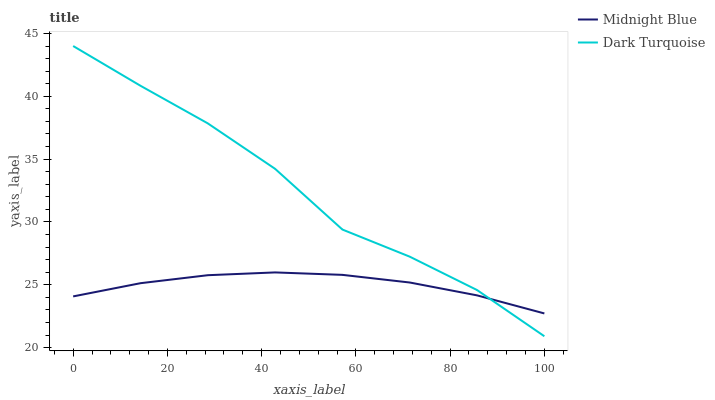Does Midnight Blue have the minimum area under the curve?
Answer yes or no. Yes. Does Dark Turquoise have the maximum area under the curve?
Answer yes or no. Yes. Does Midnight Blue have the maximum area under the curve?
Answer yes or no. No. Is Midnight Blue the smoothest?
Answer yes or no. Yes. Is Dark Turquoise the roughest?
Answer yes or no. Yes. Is Midnight Blue the roughest?
Answer yes or no. No. Does Dark Turquoise have the lowest value?
Answer yes or no. Yes. Does Midnight Blue have the lowest value?
Answer yes or no. No. Does Dark Turquoise have the highest value?
Answer yes or no. Yes. Does Midnight Blue have the highest value?
Answer yes or no. No. Does Dark Turquoise intersect Midnight Blue?
Answer yes or no. Yes. Is Dark Turquoise less than Midnight Blue?
Answer yes or no. No. Is Dark Turquoise greater than Midnight Blue?
Answer yes or no. No. 